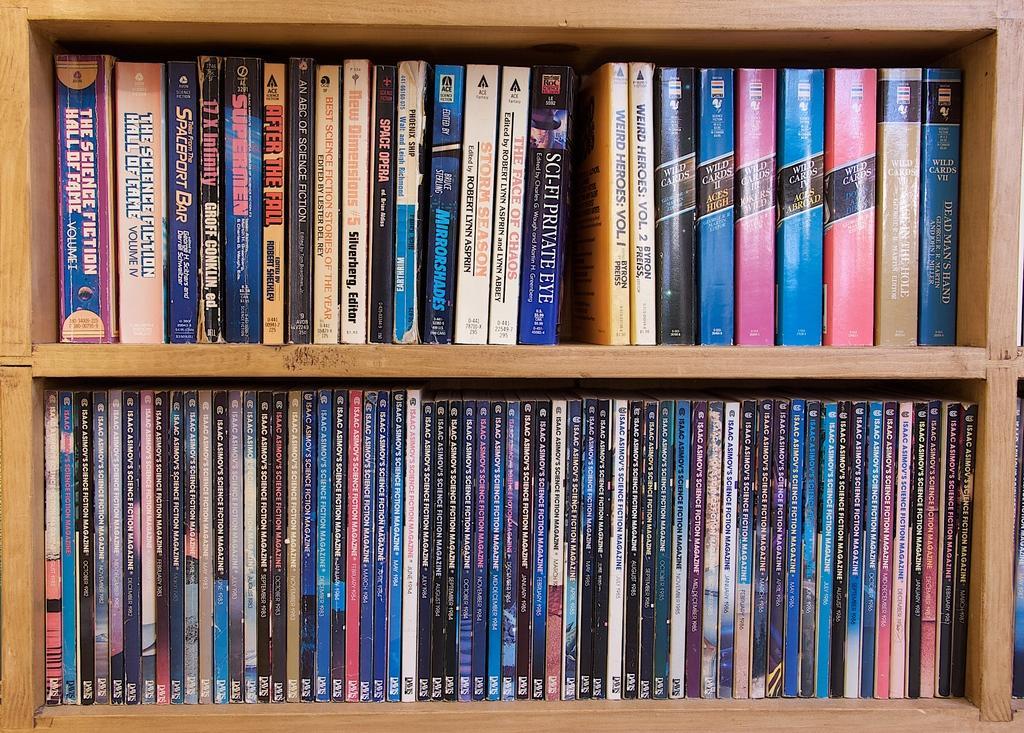Please provide a concise description of this image. In this picture we can see a wooden shelf unit full of books inside the shelf. 